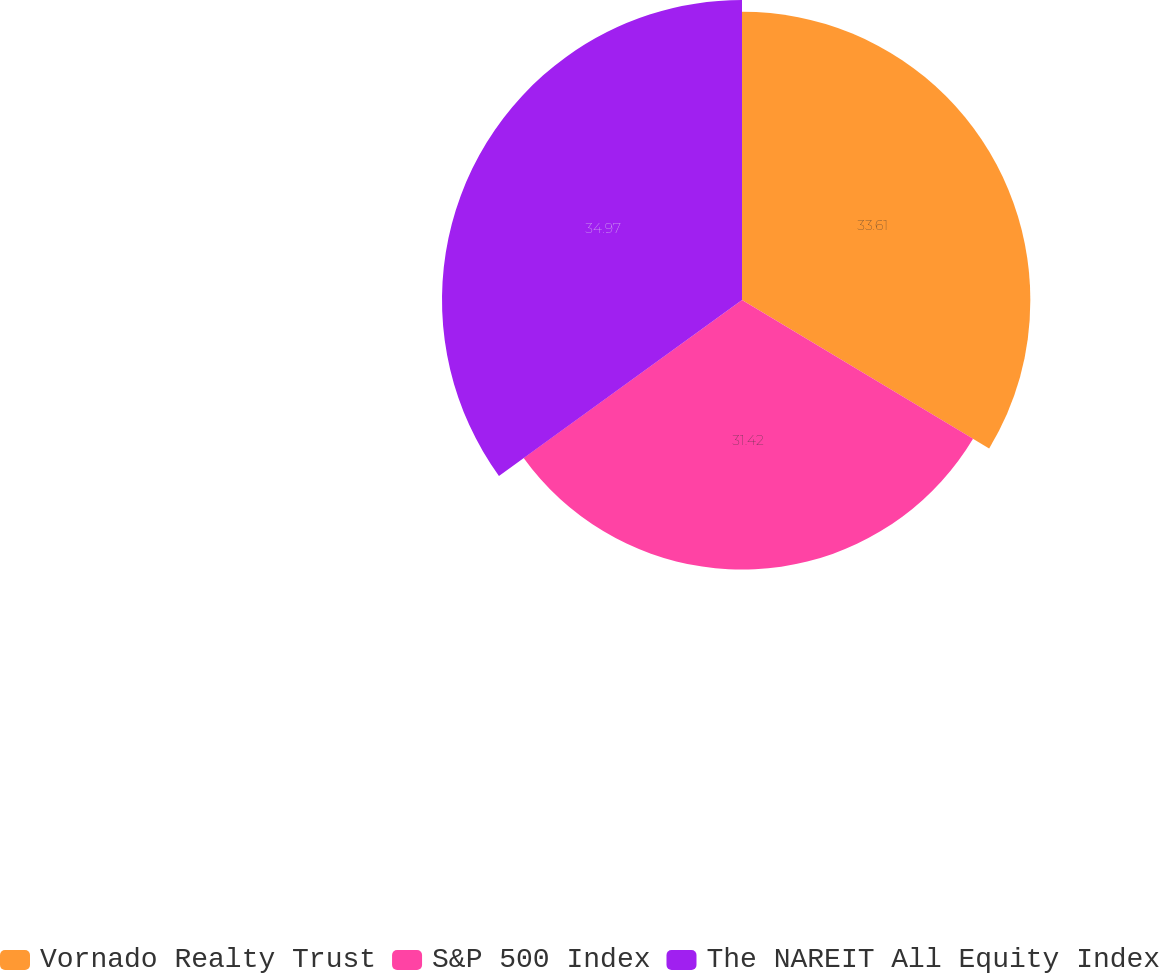<chart> <loc_0><loc_0><loc_500><loc_500><pie_chart><fcel>Vornado Realty Trust<fcel>S&P 500 Index<fcel>The NAREIT All Equity Index<nl><fcel>33.61%<fcel>31.42%<fcel>34.97%<nl></chart> 